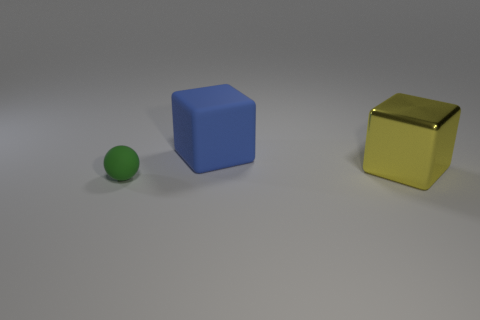Add 2 yellow rubber blocks. How many objects exist? 5 Subtract all blue cubes. How many cubes are left? 1 Subtract all red blocks. Subtract all blue cylinders. How many blocks are left? 2 Subtract 0 purple cylinders. How many objects are left? 3 Subtract all spheres. How many objects are left? 2 Subtract 1 balls. How many balls are left? 0 Subtract all green spheres. How many yellow blocks are left? 1 Subtract all large red metal cylinders. Subtract all spheres. How many objects are left? 2 Add 3 large yellow metal objects. How many large yellow metal objects are left? 4 Add 2 tiny brown rubber cylinders. How many tiny brown rubber cylinders exist? 2 